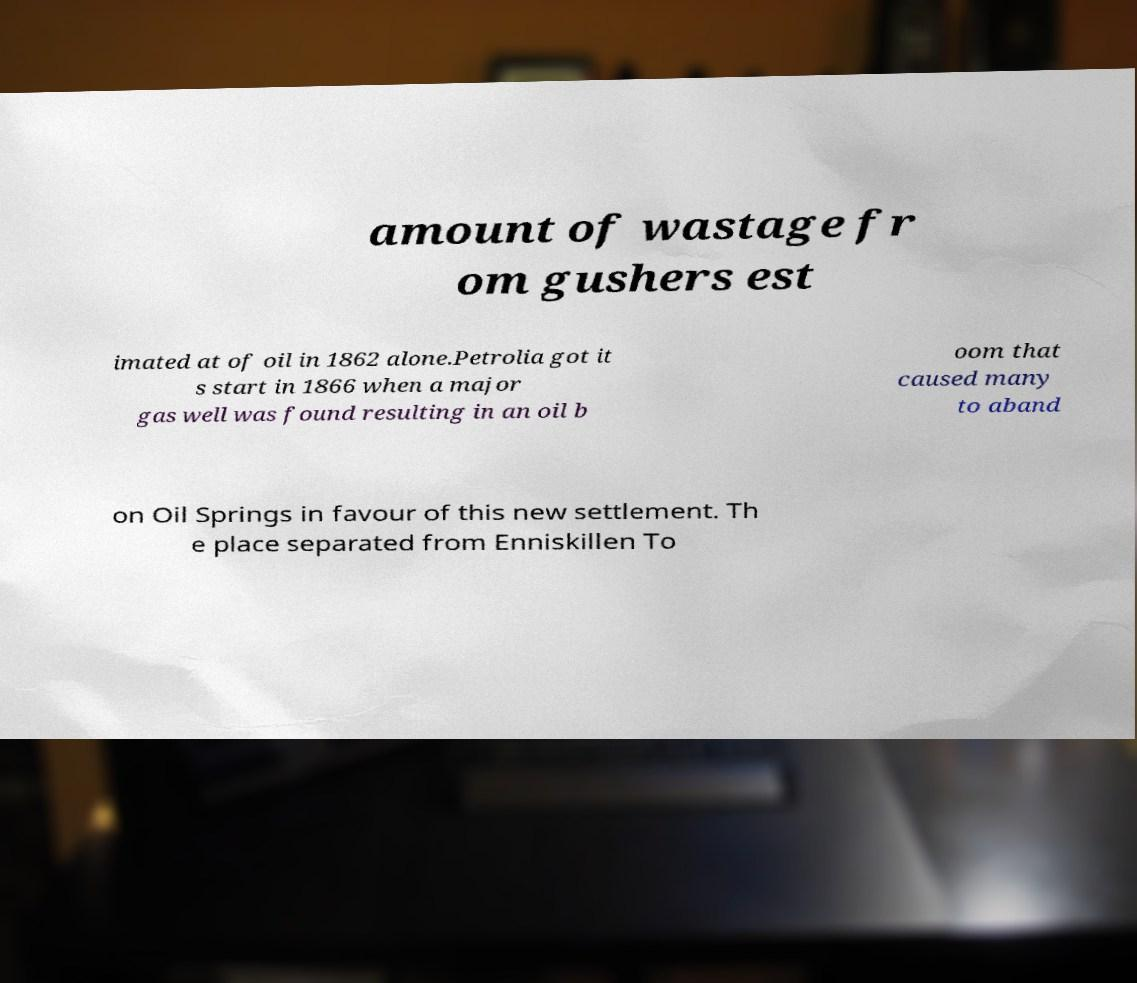Can you accurately transcribe the text from the provided image for me? amount of wastage fr om gushers est imated at of oil in 1862 alone.Petrolia got it s start in 1866 when a major gas well was found resulting in an oil b oom that caused many to aband on Oil Springs in favour of this new settlement. Th e place separated from Enniskillen To 